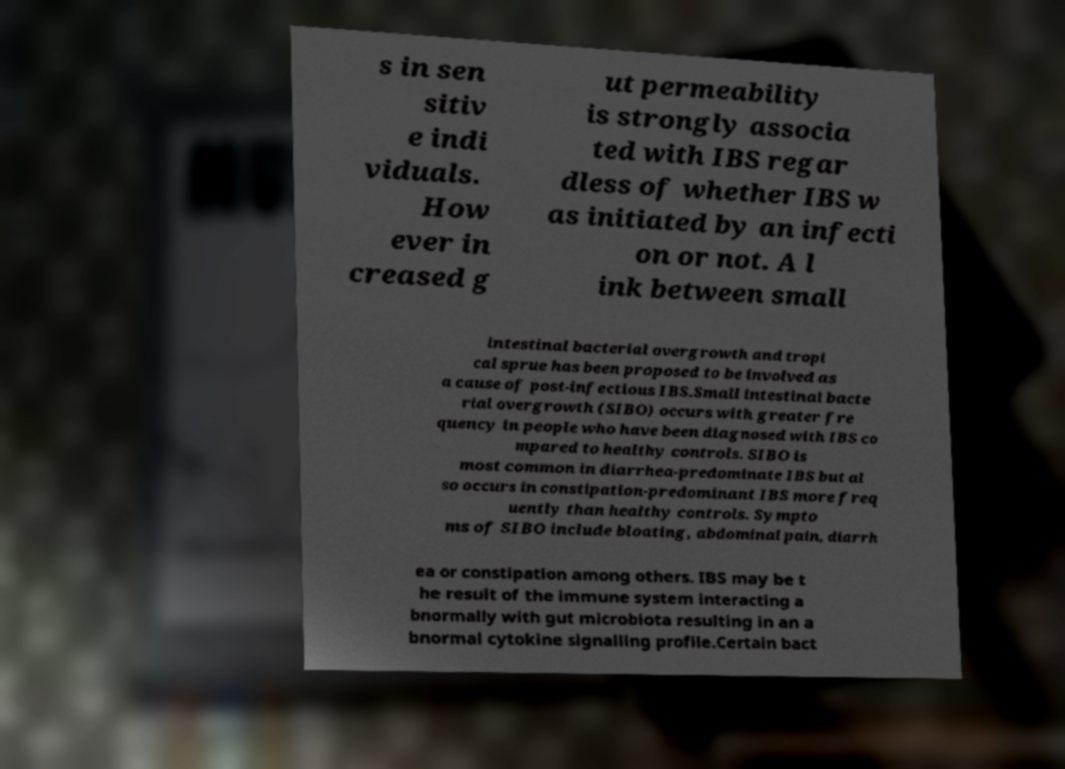Could you assist in decoding the text presented in this image and type it out clearly? s in sen sitiv e indi viduals. How ever in creased g ut permeability is strongly associa ted with IBS regar dless of whether IBS w as initiated by an infecti on or not. A l ink between small intestinal bacterial overgrowth and tropi cal sprue has been proposed to be involved as a cause of post-infectious IBS.Small intestinal bacte rial overgrowth (SIBO) occurs with greater fre quency in people who have been diagnosed with IBS co mpared to healthy controls. SIBO is most common in diarrhea-predominate IBS but al so occurs in constipation-predominant IBS more freq uently than healthy controls. Sympto ms of SIBO include bloating, abdominal pain, diarrh ea or constipation among others. IBS may be t he result of the immune system interacting a bnormally with gut microbiota resulting in an a bnormal cytokine signalling profile.Certain bact 